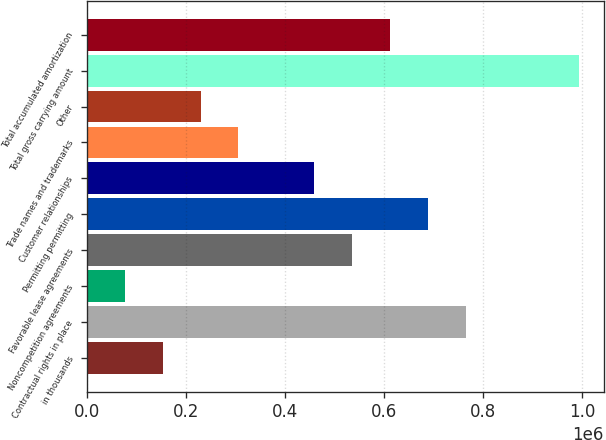Convert chart. <chart><loc_0><loc_0><loc_500><loc_500><bar_chart><fcel>in thousands<fcel>Contractual rights in place<fcel>Noncompetition agreements<fcel>Favorable lease agreements<fcel>Permitting permitting<fcel>Customer relationships<fcel>Trade names and trademarks<fcel>Other<fcel>Total gross carrying amount<fcel>Total accumulated amortization<nl><fcel>152880<fcel>764383<fcel>76442.2<fcel>535069<fcel>687945<fcel>458632<fcel>305756<fcel>229318<fcel>993697<fcel>611507<nl></chart> 